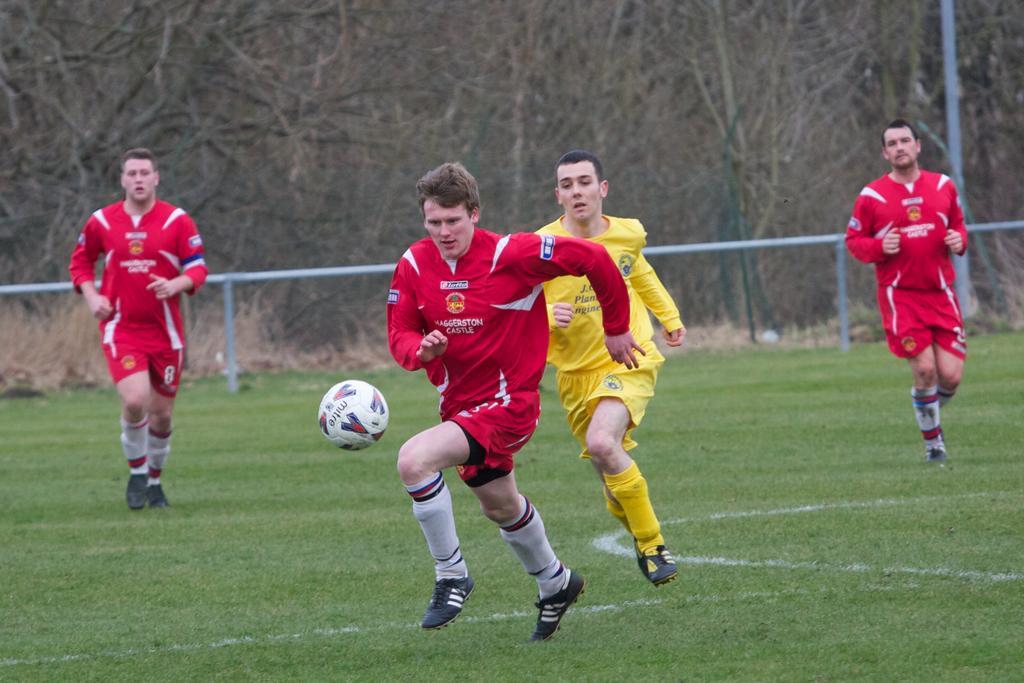Could you give a brief overview of what you see in this image? In this image, we can see four people are running on the grass. They are playing a game. Here there is a ball in the air. Background we can see rods, pole, trees and plants. 